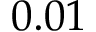Convert formula to latex. <formula><loc_0><loc_0><loc_500><loc_500>0 . 0 1</formula> 